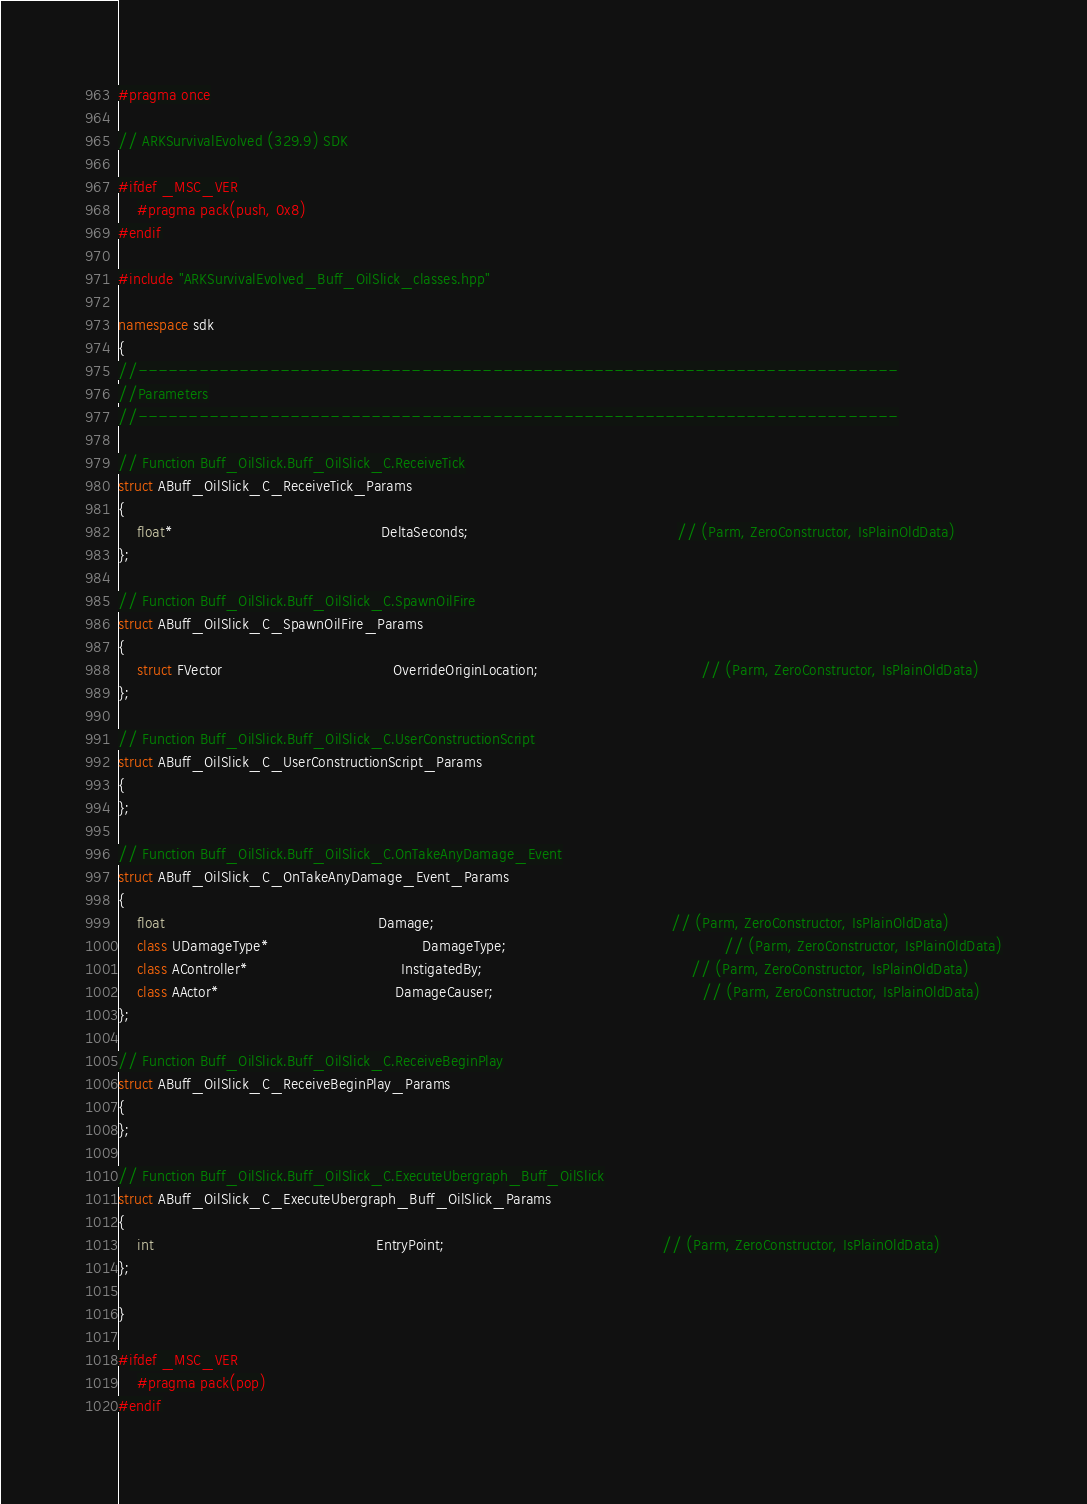<code> <loc_0><loc_0><loc_500><loc_500><_C++_>#pragma once

// ARKSurvivalEvolved (329.9) SDK

#ifdef _MSC_VER
	#pragma pack(push, 0x8)
#endif

#include "ARKSurvivalEvolved_Buff_OilSlick_classes.hpp"

namespace sdk
{
//---------------------------------------------------------------------------
//Parameters
//---------------------------------------------------------------------------

// Function Buff_OilSlick.Buff_OilSlick_C.ReceiveTick
struct ABuff_OilSlick_C_ReceiveTick_Params
{
	float*                                             DeltaSeconds;                                             // (Parm, ZeroConstructor, IsPlainOldData)
};

// Function Buff_OilSlick.Buff_OilSlick_C.SpawnOilFire
struct ABuff_OilSlick_C_SpawnOilFire_Params
{
	struct FVector                                     OverrideOriginLocation;                                   // (Parm, ZeroConstructor, IsPlainOldData)
};

// Function Buff_OilSlick.Buff_OilSlick_C.UserConstructionScript
struct ABuff_OilSlick_C_UserConstructionScript_Params
{
};

// Function Buff_OilSlick.Buff_OilSlick_C.OnTakeAnyDamage_Event
struct ABuff_OilSlick_C_OnTakeAnyDamage_Event_Params
{
	float                                              Damage;                                                   // (Parm, ZeroConstructor, IsPlainOldData)
	class UDamageType*                                 DamageType;                                               // (Parm, ZeroConstructor, IsPlainOldData)
	class AController*                                 InstigatedBy;                                             // (Parm, ZeroConstructor, IsPlainOldData)
	class AActor*                                      DamageCauser;                                             // (Parm, ZeroConstructor, IsPlainOldData)
};

// Function Buff_OilSlick.Buff_OilSlick_C.ReceiveBeginPlay
struct ABuff_OilSlick_C_ReceiveBeginPlay_Params
{
};

// Function Buff_OilSlick.Buff_OilSlick_C.ExecuteUbergraph_Buff_OilSlick
struct ABuff_OilSlick_C_ExecuteUbergraph_Buff_OilSlick_Params
{
	int                                                EntryPoint;                                               // (Parm, ZeroConstructor, IsPlainOldData)
};

}

#ifdef _MSC_VER
	#pragma pack(pop)
#endif
</code> 